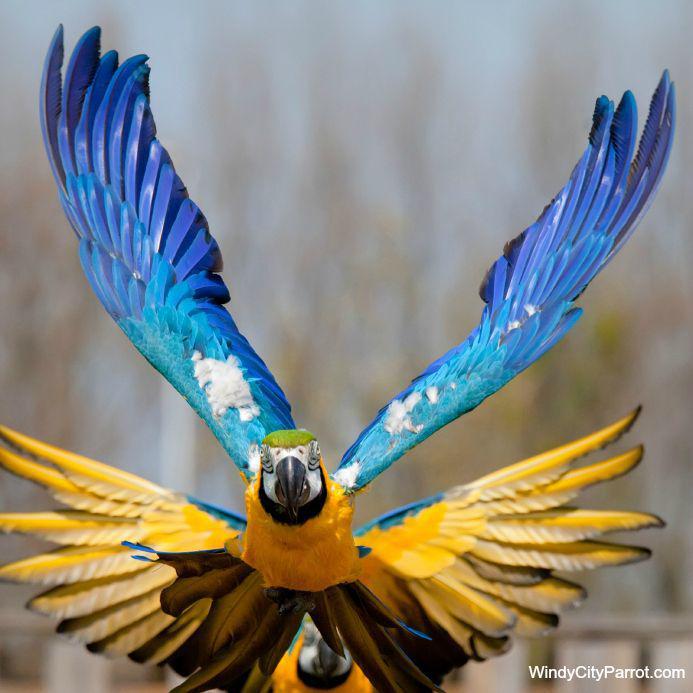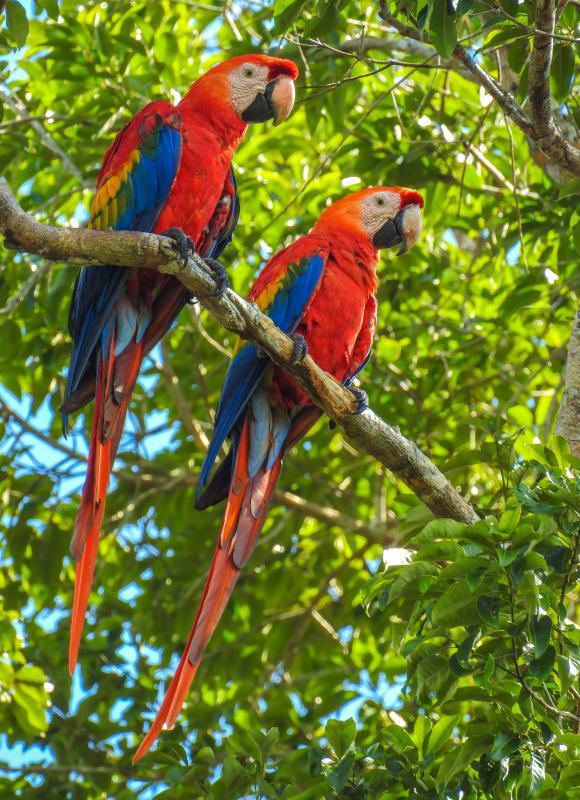The first image is the image on the left, the second image is the image on the right. Examine the images to the left and right. Is the description "The right image contains a single bird." accurate? Answer yes or no. No. 